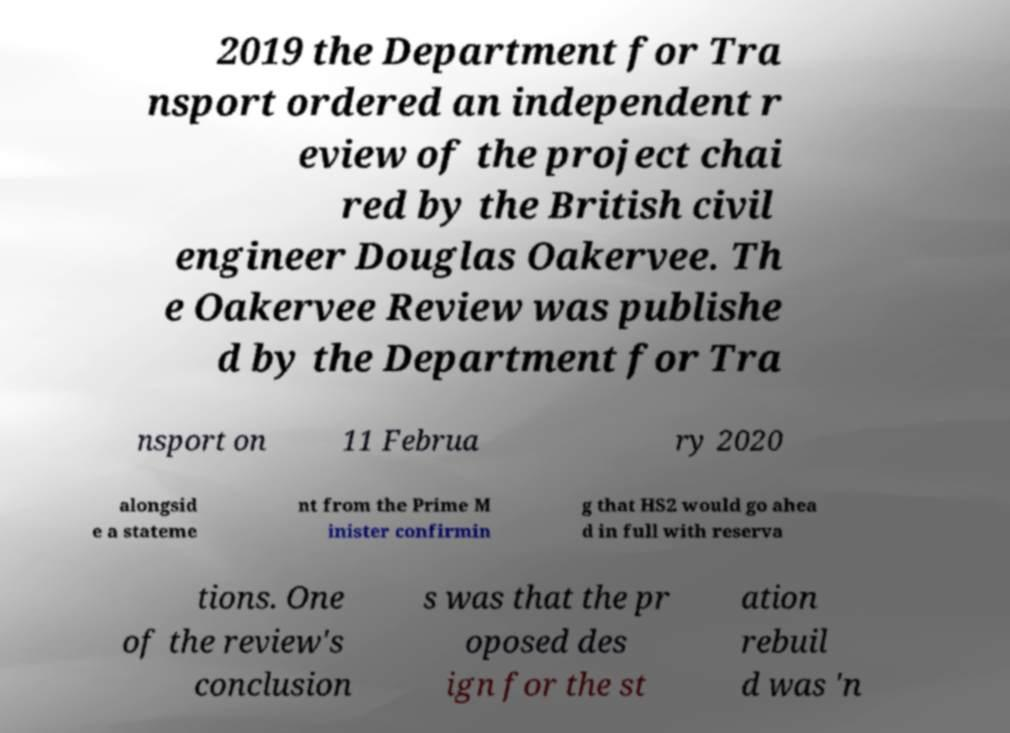There's text embedded in this image that I need extracted. Can you transcribe it verbatim? 2019 the Department for Tra nsport ordered an independent r eview of the project chai red by the British civil engineer Douglas Oakervee. Th e Oakervee Review was publishe d by the Department for Tra nsport on 11 Februa ry 2020 alongsid e a stateme nt from the Prime M inister confirmin g that HS2 would go ahea d in full with reserva tions. One of the review's conclusion s was that the pr oposed des ign for the st ation rebuil d was 'n 